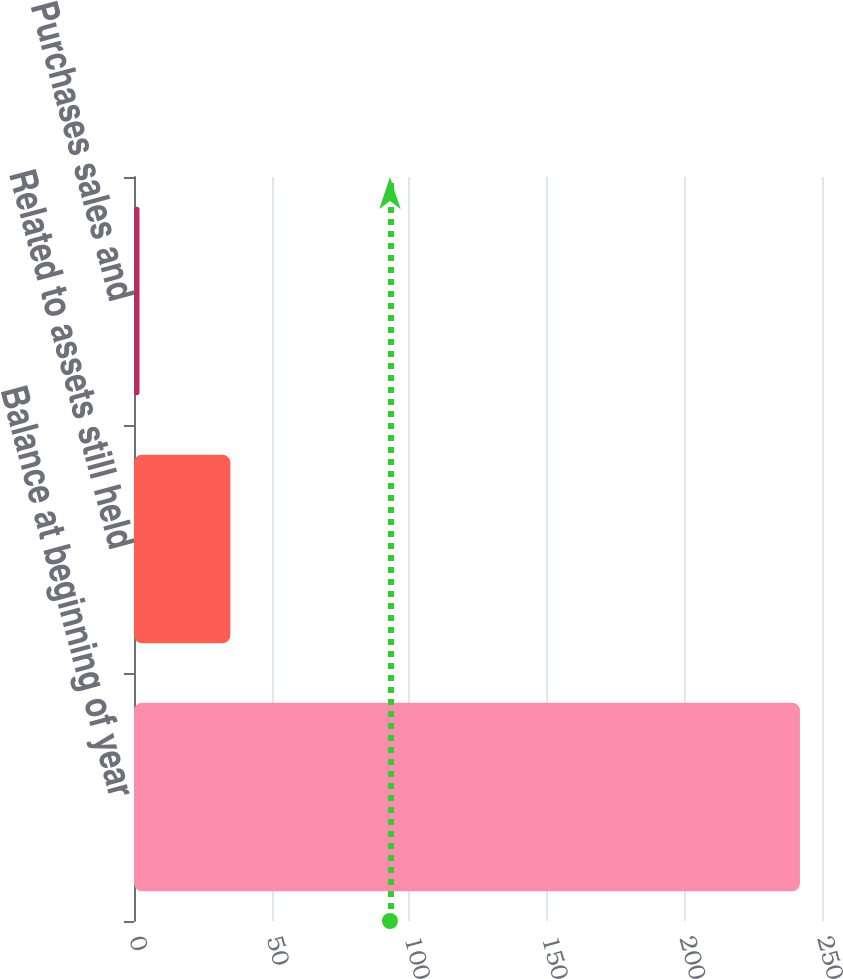Convert chart to OTSL. <chart><loc_0><loc_0><loc_500><loc_500><bar_chart><fcel>Balance at beginning of year<fcel>Related to assets still held<fcel>Purchases sales and<nl><fcel>242<fcel>35<fcel>2<nl></chart> 